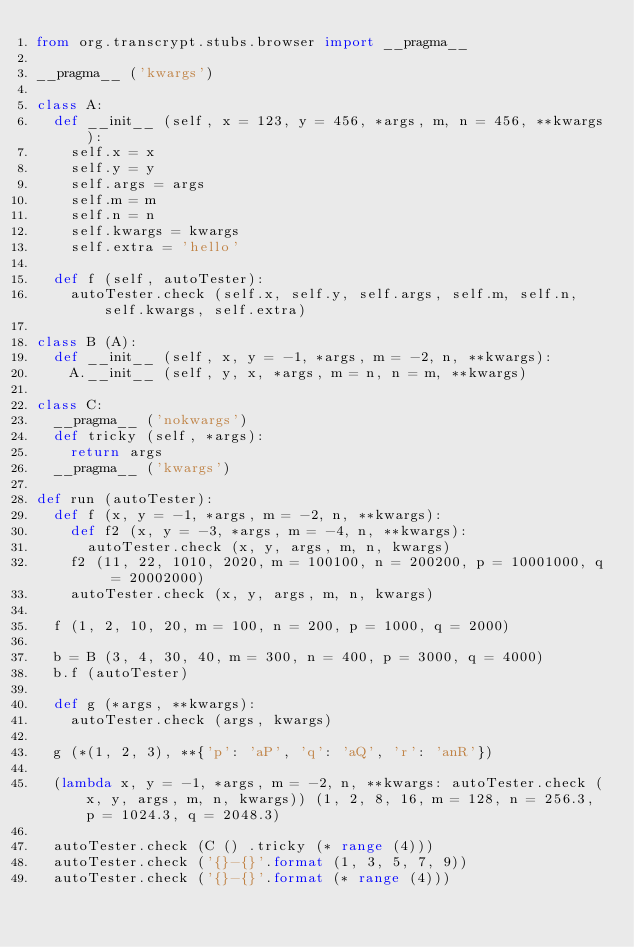<code> <loc_0><loc_0><loc_500><loc_500><_Python_>from org.transcrypt.stubs.browser import __pragma__

__pragma__ ('kwargs')

class A:
	def __init__ (self, x = 123, y = 456, *args, m, n = 456, **kwargs):
		self.x = x
		self.y = y
		self.args = args
		self.m = m
		self.n = n
		self.kwargs = kwargs
		self.extra = 'hello'

	def f (self, autoTester):
		autoTester.check (self.x, self.y, self.args, self.m, self.n, self.kwargs, self.extra)
		
class B (A):
	def __init__ (self, x, y = -1, *args, m = -2, n, **kwargs):
		A.__init__ (self, y, x, *args, m = n, n = m, **kwargs)
		
class C:
	__pragma__ ('nokwargs')
	def tricky (self, *args):
		return args
	__pragma__ ('kwargs')
	
def run (autoTester):
	def f (x, y = -1, *args, m = -2, n, **kwargs):
		def f2 (x, y = -3, *args, m = -4, n, **kwargs):
			autoTester.check (x, y, args, m, n, kwargs)
		f2 (11, 22, 1010, 2020, m = 100100, n = 200200, p = 10001000, q = 20002000)
		autoTester.check (x, y, args, m, n, kwargs)
		
	f (1, 2, 10, 20, m = 100, n = 200, p = 1000, q = 2000)
	
	b = B (3, 4, 30, 40, m = 300, n = 400, p = 3000, q = 4000)
	b.f (autoTester)
	
	def g (*args, **kwargs):
		autoTester.check (args, kwargs)
		
	g (*(1, 2, 3), **{'p': 'aP', 'q': 'aQ', 'r': 'anR'})
	
	(lambda x, y = -1, *args, m = -2, n, **kwargs: autoTester.check (x, y, args, m, n, kwargs)) (1, 2, 8, 16, m = 128, n = 256.3, p = 1024.3, q = 2048.3)
	
	autoTester.check (C () .tricky (* range (4)))
	autoTester.check ('{}-{}'.format (1, 3, 5, 7, 9))
	autoTester.check ('{}-{}'.format (* range (4)))
</code> 